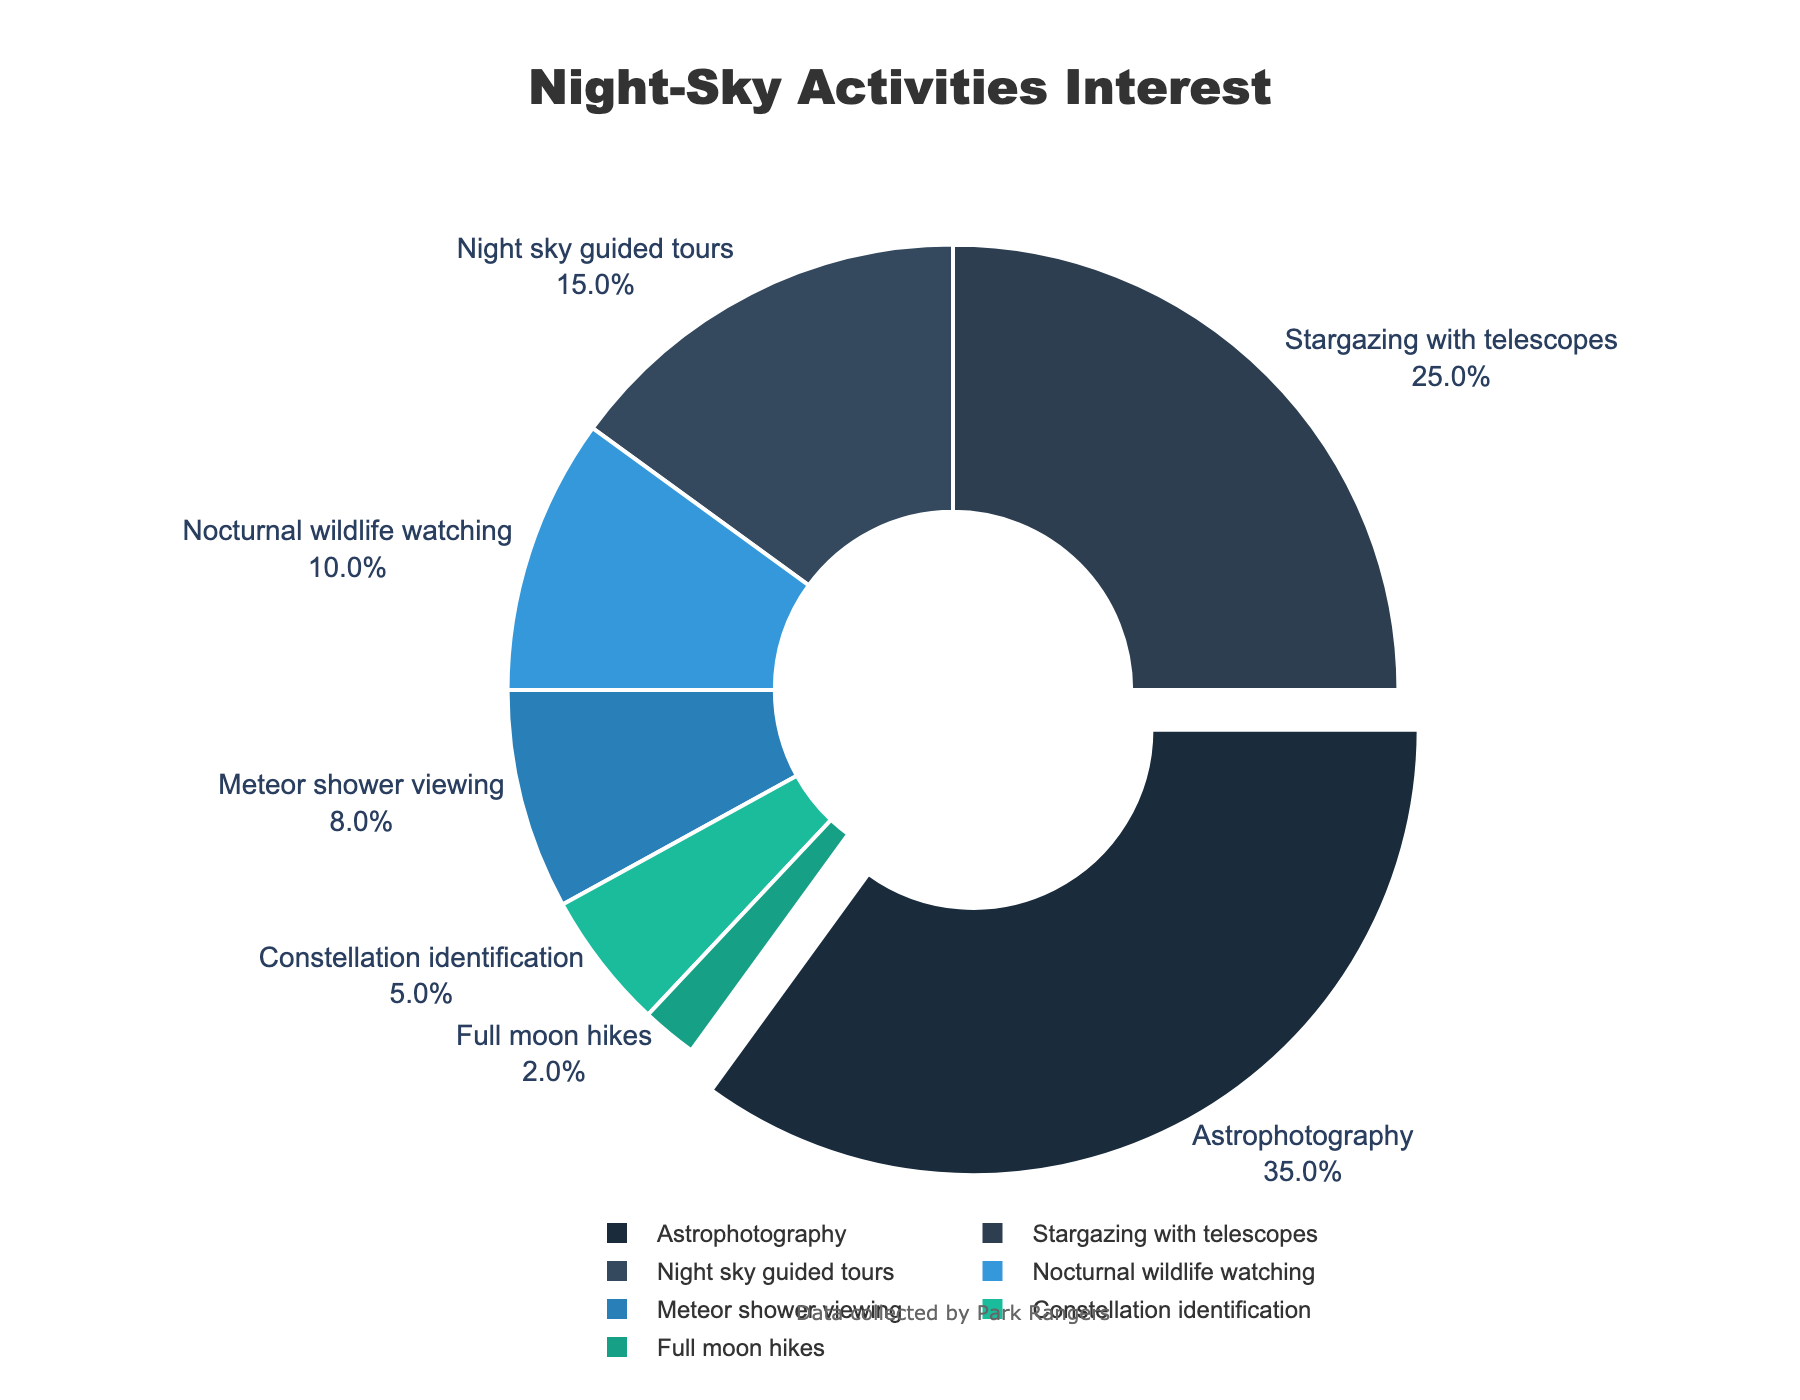Which night-sky activity is the most popular? By seeing the largest segment in the pie chart, the activity with the highest percentage is the most popular. This is the segment for Astrophotography at 35%.
Answer: Astrophotography Which two activities together make up more than half of the visitors' interests? The two activities with the highest percentages are Astrophotography (35%) and Stargazing with telescopes (25%). Adding these two gives 35% + 25% = 60%, which is more than half.
Answer: Astrophotography and Stargazing with telescopes What is the total percentage for activities related to watching the sky (Astrophotography, Stargazing with telescopes, Meteor shower viewing, Constellation identification)? Sum the percentages of each activity: Astrophotography (35%) + Stargazing with telescopes (25%) + Meteor shower viewing (8%) + Constellation identification (5%) = 73%
Answer: 73% Which activities together account for a quarter of the visitors' interests? Start by finding activities whose percentages sum to around 25%. Here, Night sky guided tours (15%) added with Nocturnal wildlife watching (10%) gives 15% + 10% = 25%.
Answer: Night sky guided tours and Nocturnal wildlife watching How much larger is the percentage of people interested in Astrophotography compared to Full moon hikes? Subtract the percentage for Full moon hikes (2%) from the percentage for Astrophotography (35%): 35% - 2% = 33%
Answer: 33% Which activity has the smallest percentage of interest and what is its value? Locate the smallest segment in the pie chart and note its percentage, which is Full moon hikes at 2%.
Answer: Full moon hikes and 2% What is the combined percentage of interest in activities involving guided experiences (Night sky guided tours and Full moon hikes)? Add the percentages of Night sky guided tours (15%) and Full moon hikes (2%): 15% + 2% = 17%
Answer: 17% By what percentage does interest in Nocturnal wildlife watching exceed interest in Constellation identification? Subtract the percentage for Constellation identification (5%) from Nocturnal wildlife watching (10%): 10% - 5% = 5%
Answer: 5% Arrange the activities in descending order of interest. List the activities by their percentages from highest to lowest: Astrophotography (35%), Stargazing with telescopes (25%), Night sky guided tours (15%), Nocturnal wildlife watching (10%), Meteor shower viewing (8%), Constellation identification (5%), Full moon hikes (2%).
Answer: Astrophotography, Stargazing with telescopes, Night sky guided tours, Nocturnal wildlife watching, Meteor shower viewing, Constellation identification, Full moon hikes 